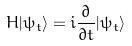<formula> <loc_0><loc_0><loc_500><loc_500>H | \psi _ { t } \rangle = i \frac { \partial } { \partial t } | \psi _ { t } \rangle</formula> 